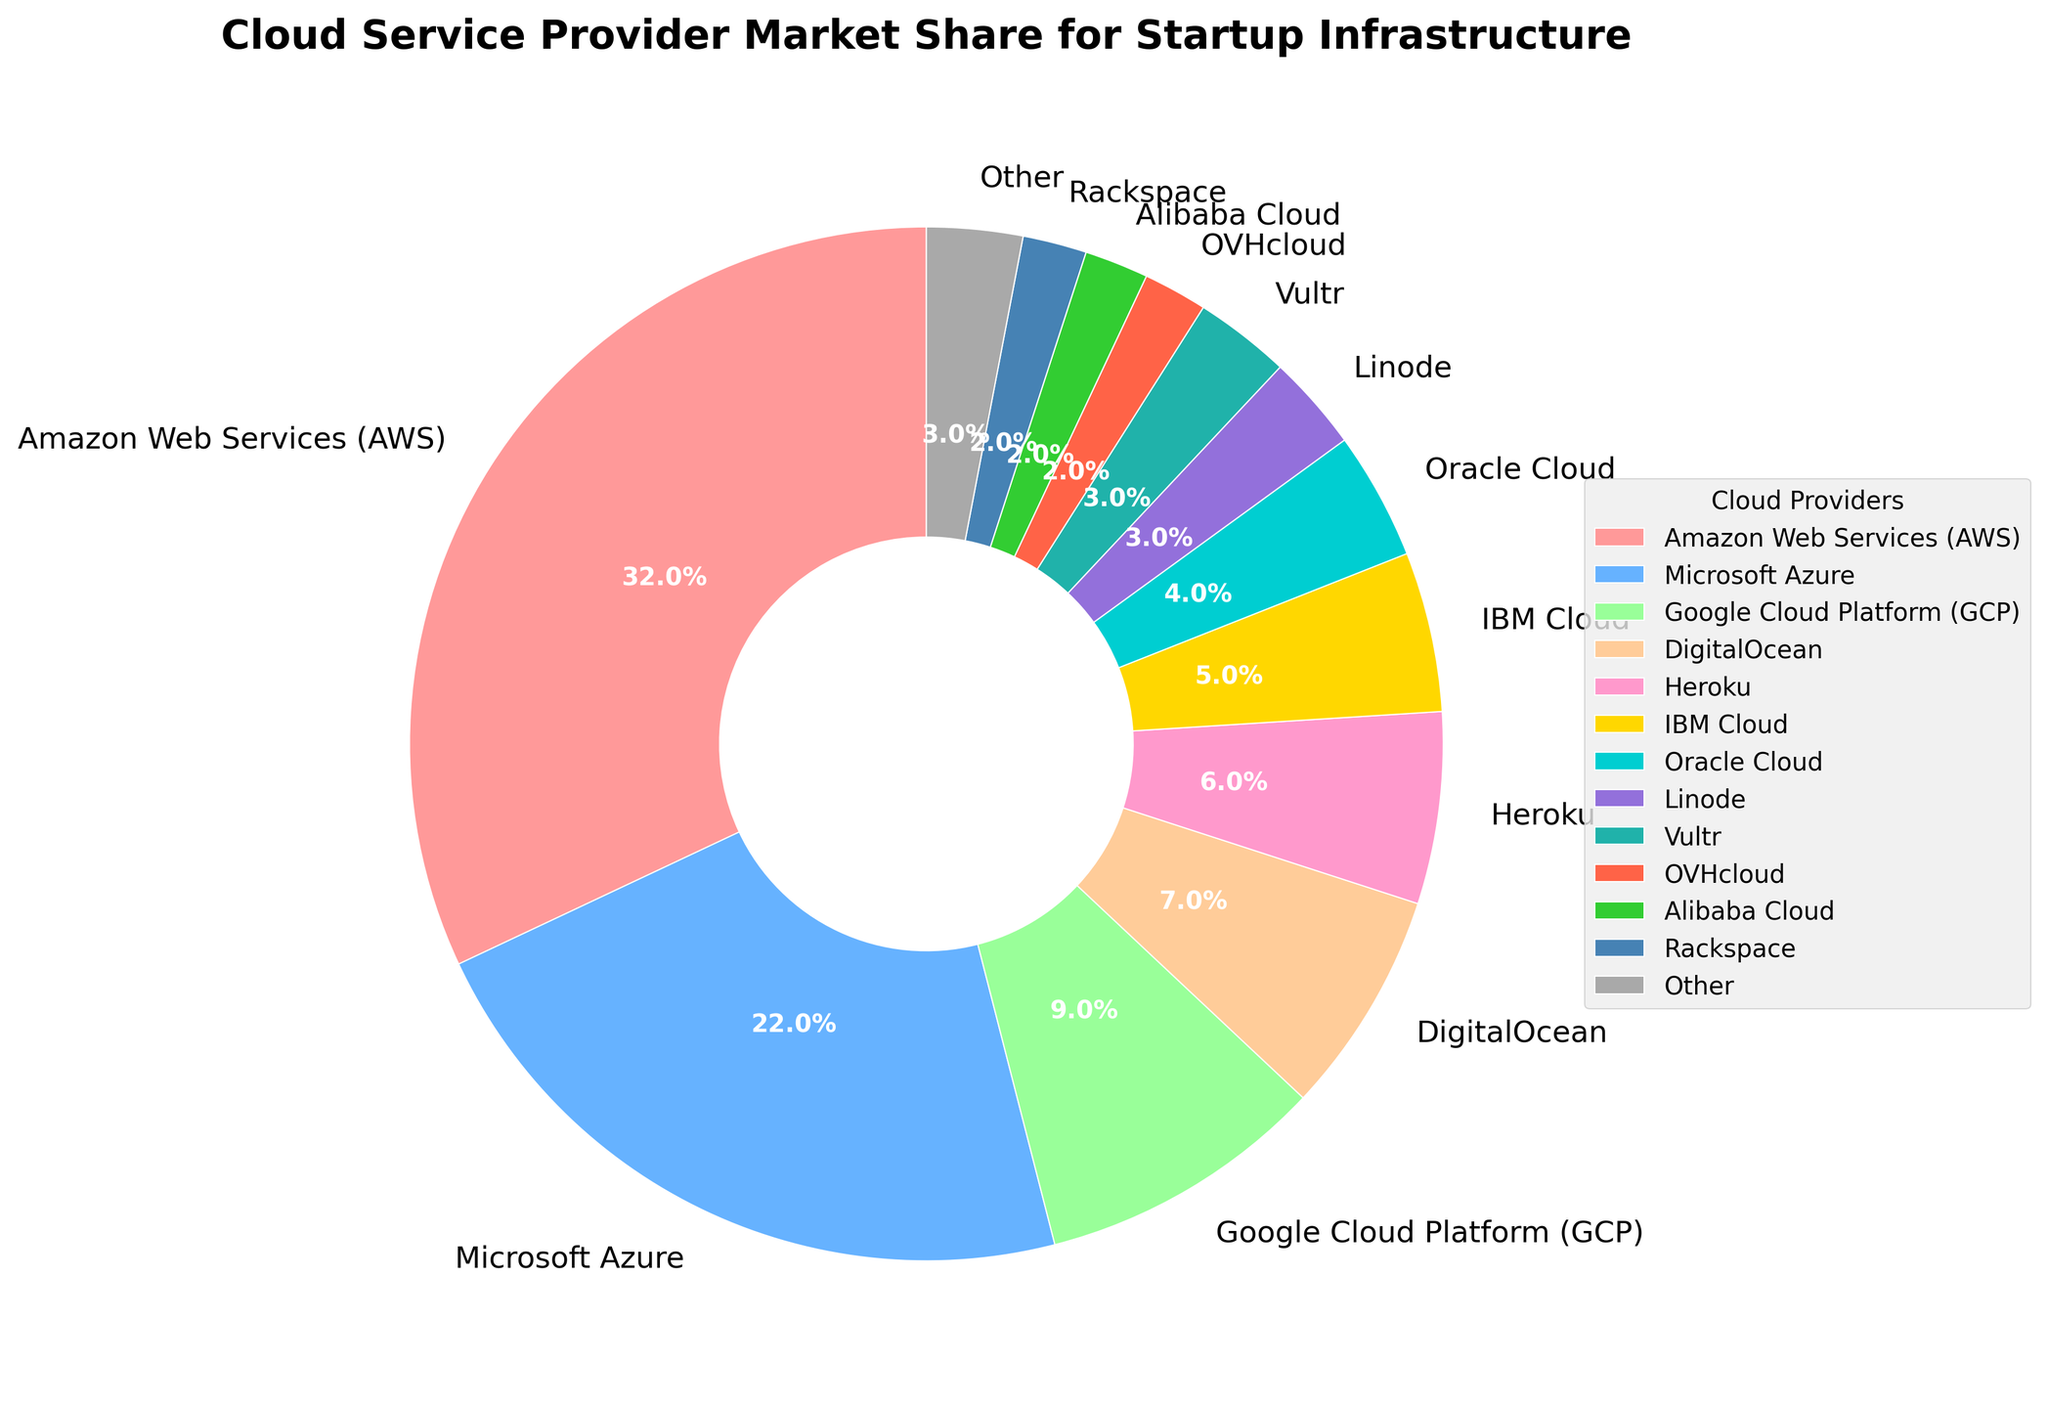Which cloud provider has the highest market share? The chart shows various cloud providers and their respective market shares. By observing the largest segment of the pie chart, we can identify that Amazon Web Services (AWS) has the highest market share.
Answer: Amazon Web Services (AWS) What is the combined market share of Microsoft Azure and Google Cloud Platform (GCP)? The market share of Microsoft Azure is 22%, and the market share of Google Cloud Platform (GCP) is 9%. Adding these two values gives us the combined market share: 22 + 9 = 31%.
Answer: 31% Which cloud provider has the smallest market share, and what is it? By looking at the smallest segment of the pie chart, we can identify that OVHcloud, Alibaba Cloud, and Rackspace each have the smallest market shares at 2%.
Answer: OVHcloud, Alibaba Cloud, and Rackspace Which cloud providers have a market share of less than 5%? From the pie chart, we can identify the cloud providers with less than 5% market share: IBM Cloud (5%), Oracle Cloud (4%), Linode (3%), Vultr (3%), OVHcloud (2%), Alibaba Cloud (2%), and Rackspace (2%). However, since we need providers strictly less than 5%, we exclude IBM Cloud.
Answer: Oracle Cloud, Linode, Vultr, OVHcloud, Alibaba Cloud, Rackspace How does the market share of Heroku compare to DigitalOcean? Heroku has a market share of 6%, while DigitalOcean has a market share of 7%. Therefore, Heroku's market share is 1% less than DigitalOcean's.
Answer: Heroku's market share is less by 1% Which cloud provider is represented by a magenta-like color? By observing the segments of the pie chart and their associated colors, we can identify that the segment with a magenta-like color (pinkish hue) corresponds to Heroku.
Answer: Heroku What is the market share difference between the cloud providers represented by golden and teal blue colors? The golden color represents IBM Cloud with a 5% market share, and the teal blue color represents Vultr with a 3% market share. The difference is 5 - 3 = 2%.
Answer: 2% How many cloud providers have a market share greater than or equal to 10%? By inspecting the pie chart, we see Amazon Web Services (32%) and Microsoft Azure (22%), which have market shares greater than or equal to 10%. These are the only two providers meeting this criterion.
Answer: 2 What's the market share of providers collectively labeled as "Other"? The pie chart includes a segment labeled as "Other" that aggregates smaller providers. The market share of "Other" is shown as 3%.
Answer: 3% What is the total market share of all providers excluding Amazon Web Services (AWS)? AWS has a 32% market share. The total market share must sum to 100%. Excluding AWS means subtracting AWS's share from 100%: 100 - 32 = 68%.
Answer: 68% 